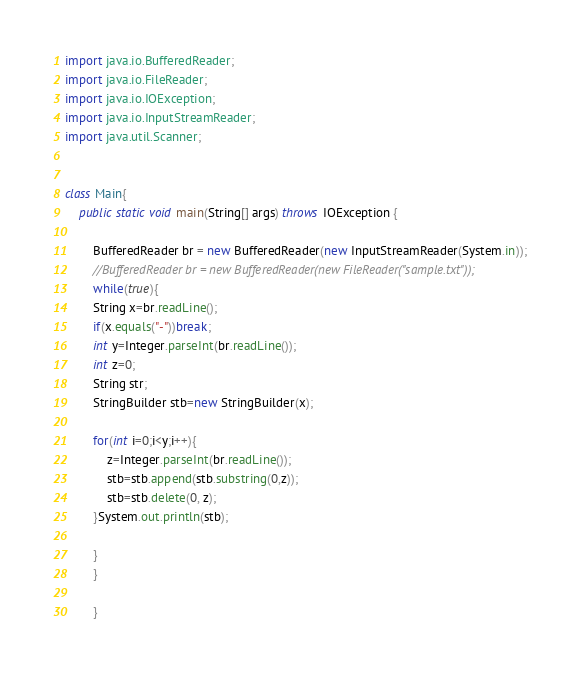Convert code to text. <code><loc_0><loc_0><loc_500><loc_500><_Java_>import java.io.BufferedReader;
import java.io.FileReader;
import java.io.IOException;
import java.io.InputStreamReader;
import java.util.Scanner;


class Main{
	public static void main(String[] args) throws IOException {

		BufferedReader br = new BufferedReader(new InputStreamReader(System.in));
		//BufferedReader br = new BufferedReader(new FileReader("sample.txt"));
		while(true){
		String x=br.readLine();
		if(x.equals("-"))break;
		int y=Integer.parseInt(br.readLine());
		int z=0;
		String str;
		StringBuilder stb=new StringBuilder(x);
		
		for(int i=0;i<y;i++){
			z=Integer.parseInt(br.readLine());
			stb=stb.append(stb.substring(0,z));
			stb=stb.delete(0, z);
		}System.out.println(stb);
		
		}
		}
		
		}</code> 